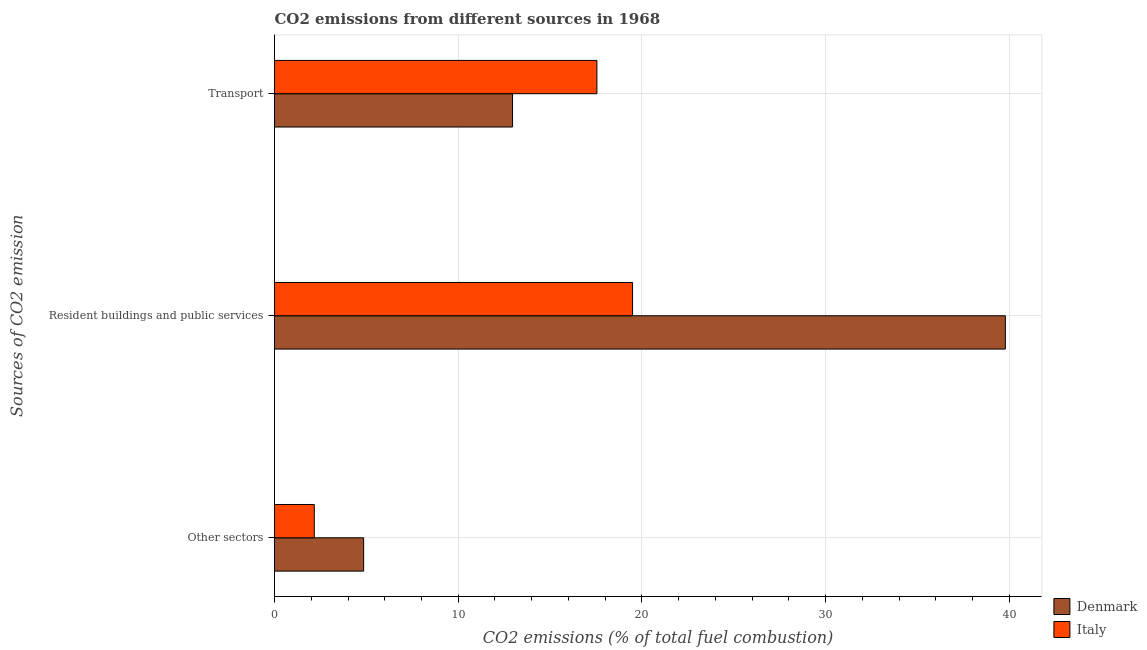How many bars are there on the 1st tick from the bottom?
Your response must be concise. 2. What is the label of the 3rd group of bars from the top?
Your response must be concise. Other sectors. What is the percentage of co2 emissions from resident buildings and public services in Italy?
Offer a very short reply. 19.49. Across all countries, what is the maximum percentage of co2 emissions from resident buildings and public services?
Your answer should be compact. 39.79. Across all countries, what is the minimum percentage of co2 emissions from transport?
Your answer should be very brief. 12.96. What is the total percentage of co2 emissions from transport in the graph?
Your answer should be compact. 30.51. What is the difference between the percentage of co2 emissions from other sectors in Italy and that in Denmark?
Make the answer very short. -2.69. What is the difference between the percentage of co2 emissions from resident buildings and public services in Italy and the percentage of co2 emissions from other sectors in Denmark?
Your answer should be compact. 14.64. What is the average percentage of co2 emissions from resident buildings and public services per country?
Give a very brief answer. 29.64. What is the difference between the percentage of co2 emissions from transport and percentage of co2 emissions from other sectors in Denmark?
Ensure brevity in your answer.  8.11. In how many countries, is the percentage of co2 emissions from resident buildings and public services greater than 18 %?
Make the answer very short. 2. What is the ratio of the percentage of co2 emissions from other sectors in Italy to that in Denmark?
Offer a very short reply. 0.45. What is the difference between the highest and the second highest percentage of co2 emissions from other sectors?
Your answer should be very brief. 2.69. What is the difference between the highest and the lowest percentage of co2 emissions from other sectors?
Your response must be concise. 2.69. Is the sum of the percentage of co2 emissions from other sectors in Denmark and Italy greater than the maximum percentage of co2 emissions from resident buildings and public services across all countries?
Your response must be concise. No. How many bars are there?
Make the answer very short. 6. Are all the bars in the graph horizontal?
Offer a very short reply. Yes. Does the graph contain any zero values?
Provide a short and direct response. No. Does the graph contain grids?
Your answer should be very brief. Yes. What is the title of the graph?
Offer a terse response. CO2 emissions from different sources in 1968. Does "Ethiopia" appear as one of the legend labels in the graph?
Offer a terse response. No. What is the label or title of the X-axis?
Provide a succinct answer. CO2 emissions (% of total fuel combustion). What is the label or title of the Y-axis?
Make the answer very short. Sources of CO2 emission. What is the CO2 emissions (% of total fuel combustion) of Denmark in Other sectors?
Make the answer very short. 4.85. What is the CO2 emissions (% of total fuel combustion) of Italy in Other sectors?
Make the answer very short. 2.16. What is the CO2 emissions (% of total fuel combustion) of Denmark in Resident buildings and public services?
Your response must be concise. 39.79. What is the CO2 emissions (% of total fuel combustion) of Italy in Resident buildings and public services?
Your answer should be compact. 19.49. What is the CO2 emissions (% of total fuel combustion) in Denmark in Transport?
Offer a terse response. 12.96. What is the CO2 emissions (% of total fuel combustion) in Italy in Transport?
Ensure brevity in your answer.  17.55. Across all Sources of CO2 emission, what is the maximum CO2 emissions (% of total fuel combustion) of Denmark?
Your answer should be compact. 39.79. Across all Sources of CO2 emission, what is the maximum CO2 emissions (% of total fuel combustion) of Italy?
Offer a terse response. 19.49. Across all Sources of CO2 emission, what is the minimum CO2 emissions (% of total fuel combustion) in Denmark?
Give a very brief answer. 4.85. Across all Sources of CO2 emission, what is the minimum CO2 emissions (% of total fuel combustion) of Italy?
Keep it short and to the point. 2.16. What is the total CO2 emissions (% of total fuel combustion) of Denmark in the graph?
Ensure brevity in your answer.  57.6. What is the total CO2 emissions (% of total fuel combustion) in Italy in the graph?
Keep it short and to the point. 39.21. What is the difference between the CO2 emissions (% of total fuel combustion) of Denmark in Other sectors and that in Resident buildings and public services?
Ensure brevity in your answer.  -34.94. What is the difference between the CO2 emissions (% of total fuel combustion) in Italy in Other sectors and that in Resident buildings and public services?
Make the answer very short. -17.33. What is the difference between the CO2 emissions (% of total fuel combustion) of Denmark in Other sectors and that in Transport?
Offer a terse response. -8.11. What is the difference between the CO2 emissions (% of total fuel combustion) in Italy in Other sectors and that in Transport?
Provide a short and direct response. -15.39. What is the difference between the CO2 emissions (% of total fuel combustion) in Denmark in Resident buildings and public services and that in Transport?
Your response must be concise. 26.83. What is the difference between the CO2 emissions (% of total fuel combustion) of Italy in Resident buildings and public services and that in Transport?
Give a very brief answer. 1.94. What is the difference between the CO2 emissions (% of total fuel combustion) of Denmark in Other sectors and the CO2 emissions (% of total fuel combustion) of Italy in Resident buildings and public services?
Ensure brevity in your answer.  -14.64. What is the difference between the CO2 emissions (% of total fuel combustion) of Denmark in Other sectors and the CO2 emissions (% of total fuel combustion) of Italy in Transport?
Offer a very short reply. -12.7. What is the difference between the CO2 emissions (% of total fuel combustion) in Denmark in Resident buildings and public services and the CO2 emissions (% of total fuel combustion) in Italy in Transport?
Offer a very short reply. 22.24. What is the average CO2 emissions (% of total fuel combustion) in Denmark per Sources of CO2 emission?
Your answer should be very brief. 19.2. What is the average CO2 emissions (% of total fuel combustion) in Italy per Sources of CO2 emission?
Make the answer very short. 13.07. What is the difference between the CO2 emissions (% of total fuel combustion) in Denmark and CO2 emissions (% of total fuel combustion) in Italy in Other sectors?
Keep it short and to the point. 2.69. What is the difference between the CO2 emissions (% of total fuel combustion) of Denmark and CO2 emissions (% of total fuel combustion) of Italy in Resident buildings and public services?
Give a very brief answer. 20.3. What is the difference between the CO2 emissions (% of total fuel combustion) of Denmark and CO2 emissions (% of total fuel combustion) of Italy in Transport?
Your answer should be compact. -4.59. What is the ratio of the CO2 emissions (% of total fuel combustion) in Denmark in Other sectors to that in Resident buildings and public services?
Your answer should be very brief. 0.12. What is the ratio of the CO2 emissions (% of total fuel combustion) in Italy in Other sectors to that in Resident buildings and public services?
Your answer should be very brief. 0.11. What is the ratio of the CO2 emissions (% of total fuel combustion) in Denmark in Other sectors to that in Transport?
Offer a terse response. 0.37. What is the ratio of the CO2 emissions (% of total fuel combustion) in Italy in Other sectors to that in Transport?
Offer a terse response. 0.12. What is the ratio of the CO2 emissions (% of total fuel combustion) of Denmark in Resident buildings and public services to that in Transport?
Offer a very short reply. 3.07. What is the ratio of the CO2 emissions (% of total fuel combustion) in Italy in Resident buildings and public services to that in Transport?
Your response must be concise. 1.11. What is the difference between the highest and the second highest CO2 emissions (% of total fuel combustion) of Denmark?
Provide a succinct answer. 26.83. What is the difference between the highest and the second highest CO2 emissions (% of total fuel combustion) in Italy?
Keep it short and to the point. 1.94. What is the difference between the highest and the lowest CO2 emissions (% of total fuel combustion) in Denmark?
Make the answer very short. 34.94. What is the difference between the highest and the lowest CO2 emissions (% of total fuel combustion) in Italy?
Offer a very short reply. 17.33. 